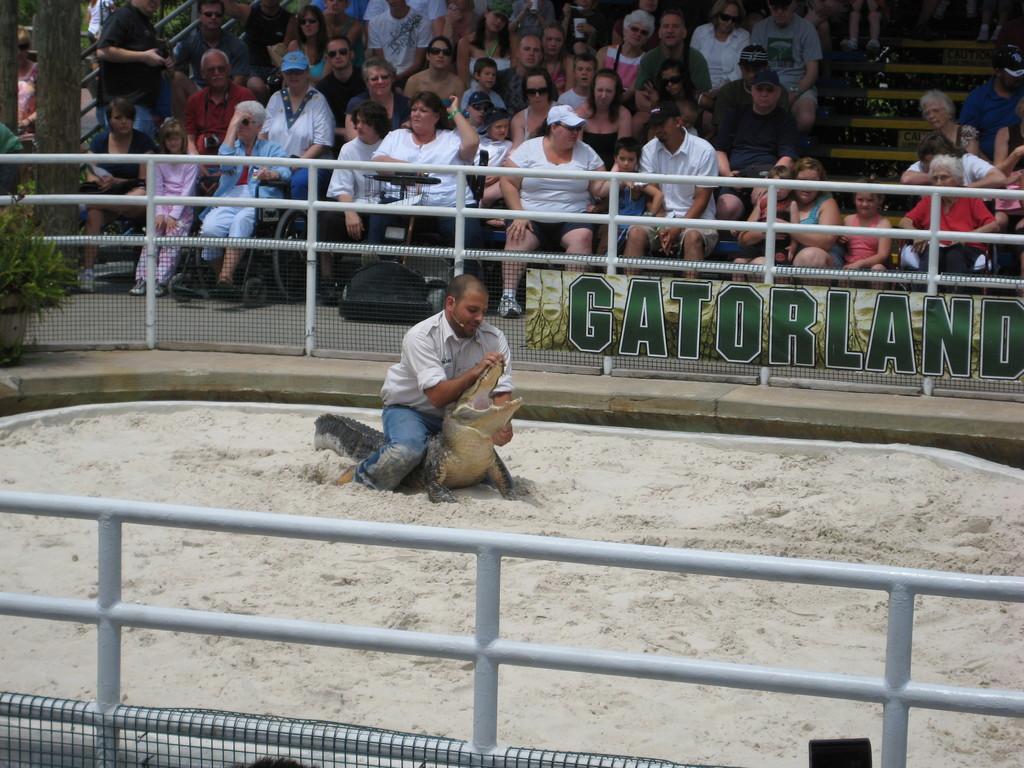In one or two sentences, can you explain what this image depicts? In this image, we can see a person wearing clothes and sitting on the crocodile. There is a crowd in front of the fencing. There is an another fencing at the bottom of the image. 